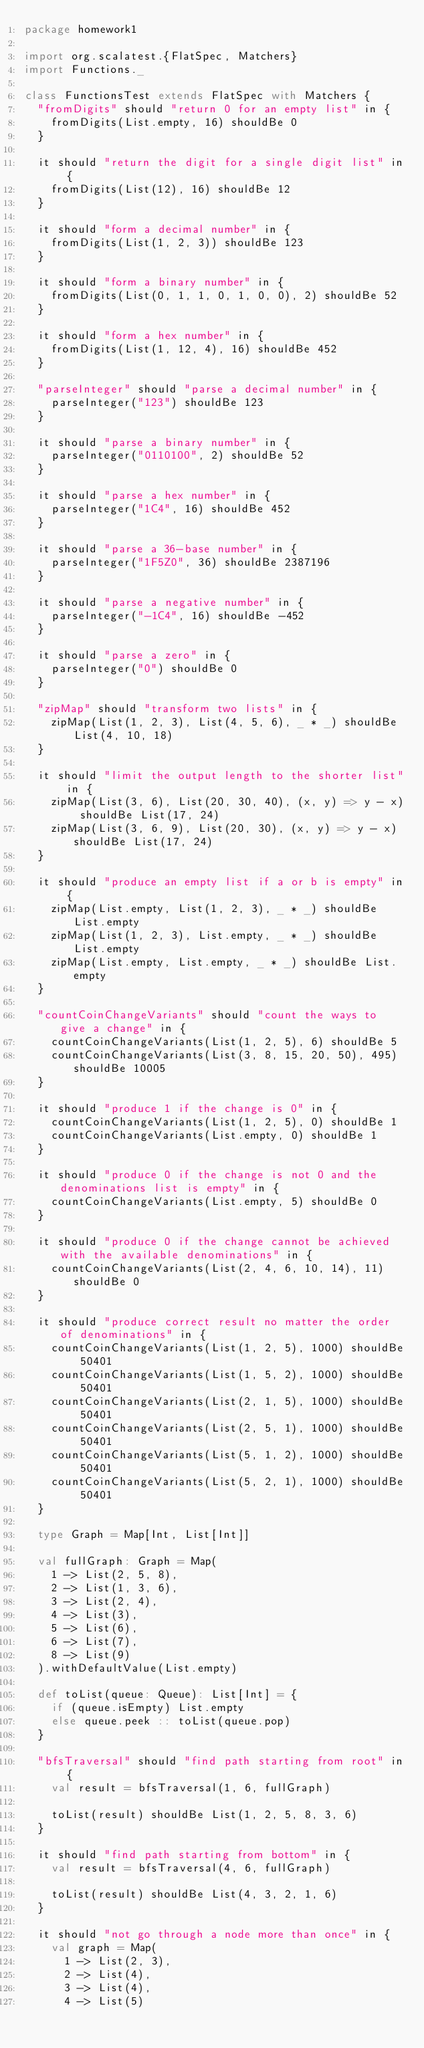<code> <loc_0><loc_0><loc_500><loc_500><_Scala_>package homework1

import org.scalatest.{FlatSpec, Matchers}
import Functions._

class FunctionsTest extends FlatSpec with Matchers {
  "fromDigits" should "return 0 for an empty list" in {
    fromDigits(List.empty, 16) shouldBe 0
  }

  it should "return the digit for a single digit list" in {
    fromDigits(List(12), 16) shouldBe 12
  }

  it should "form a decimal number" in {
    fromDigits(List(1, 2, 3)) shouldBe 123
  }

  it should "form a binary number" in {
    fromDigits(List(0, 1, 1, 0, 1, 0, 0), 2) shouldBe 52
  }

  it should "form a hex number" in {
    fromDigits(List(1, 12, 4), 16) shouldBe 452
  }

  "parseInteger" should "parse a decimal number" in {
    parseInteger("123") shouldBe 123
  }

  it should "parse a binary number" in {
    parseInteger("0110100", 2) shouldBe 52
  }

  it should "parse a hex number" in {
    parseInteger("1C4", 16) shouldBe 452
  }

  it should "parse a 36-base number" in {
    parseInteger("1F5Z0", 36) shouldBe 2387196
  }

  it should "parse a negative number" in {
    parseInteger("-1C4", 16) shouldBe -452
  }

  it should "parse a zero" in {
    parseInteger("0") shouldBe 0
  }

  "zipMap" should "transform two lists" in {
    zipMap(List(1, 2, 3), List(4, 5, 6), _ * _) shouldBe List(4, 10, 18)
  }

  it should "limit the output length to the shorter list" in {
    zipMap(List(3, 6), List(20, 30, 40), (x, y) => y - x) shouldBe List(17, 24)
    zipMap(List(3, 6, 9), List(20, 30), (x, y) => y - x) shouldBe List(17, 24)
  }

  it should "produce an empty list if a or b is empty" in {
    zipMap(List.empty, List(1, 2, 3), _ * _) shouldBe List.empty
    zipMap(List(1, 2, 3), List.empty, _ * _) shouldBe List.empty
    zipMap(List.empty, List.empty, _ * _) shouldBe List.empty
  }

  "countCoinChangeVariants" should "count the ways to give a change" in {
    countCoinChangeVariants(List(1, 2, 5), 6) shouldBe 5
    countCoinChangeVariants(List(3, 8, 15, 20, 50), 495) shouldBe 10005
  }

  it should "produce 1 if the change is 0" in {
    countCoinChangeVariants(List(1, 2, 5), 0) shouldBe 1
    countCoinChangeVariants(List.empty, 0) shouldBe 1
  }

  it should "produce 0 if the change is not 0 and the denominations list is empty" in {
    countCoinChangeVariants(List.empty, 5) shouldBe 0
  }

  it should "produce 0 if the change cannot be achieved with the available denominations" in {
    countCoinChangeVariants(List(2, 4, 6, 10, 14), 11) shouldBe 0
  }

  it should "produce correct result no matter the order of denominations" in {
    countCoinChangeVariants(List(1, 2, 5), 1000) shouldBe 50401
    countCoinChangeVariants(List(1, 5, 2), 1000) shouldBe 50401
    countCoinChangeVariants(List(2, 1, 5), 1000) shouldBe 50401
    countCoinChangeVariants(List(2, 5, 1), 1000) shouldBe 50401
    countCoinChangeVariants(List(5, 1, 2), 1000) shouldBe 50401
    countCoinChangeVariants(List(5, 2, 1), 1000) shouldBe 50401
  }

  type Graph = Map[Int, List[Int]]

  val fullGraph: Graph = Map(
    1 -> List(2, 5, 8),
    2 -> List(1, 3, 6),
    3 -> List(2, 4),
    4 -> List(3),
    5 -> List(6),
    6 -> List(7),
    8 -> List(9)
  ).withDefaultValue(List.empty)

  def toList(queue: Queue): List[Int] = {
    if (queue.isEmpty) List.empty
    else queue.peek :: toList(queue.pop)
  }

  "bfsTraversal" should "find path starting from root" in {
    val result = bfsTraversal(1, 6, fullGraph)

    toList(result) shouldBe List(1, 2, 5, 8, 3, 6)
  }

  it should "find path starting from bottom" in {
    val result = bfsTraversal(4, 6, fullGraph)

    toList(result) shouldBe List(4, 3, 2, 1, 6)
  }

  it should "not go through a node more than once" in {
    val graph = Map(
      1 -> List(2, 3),
      2 -> List(4),
      3 -> List(4),
      4 -> List(5)</code> 